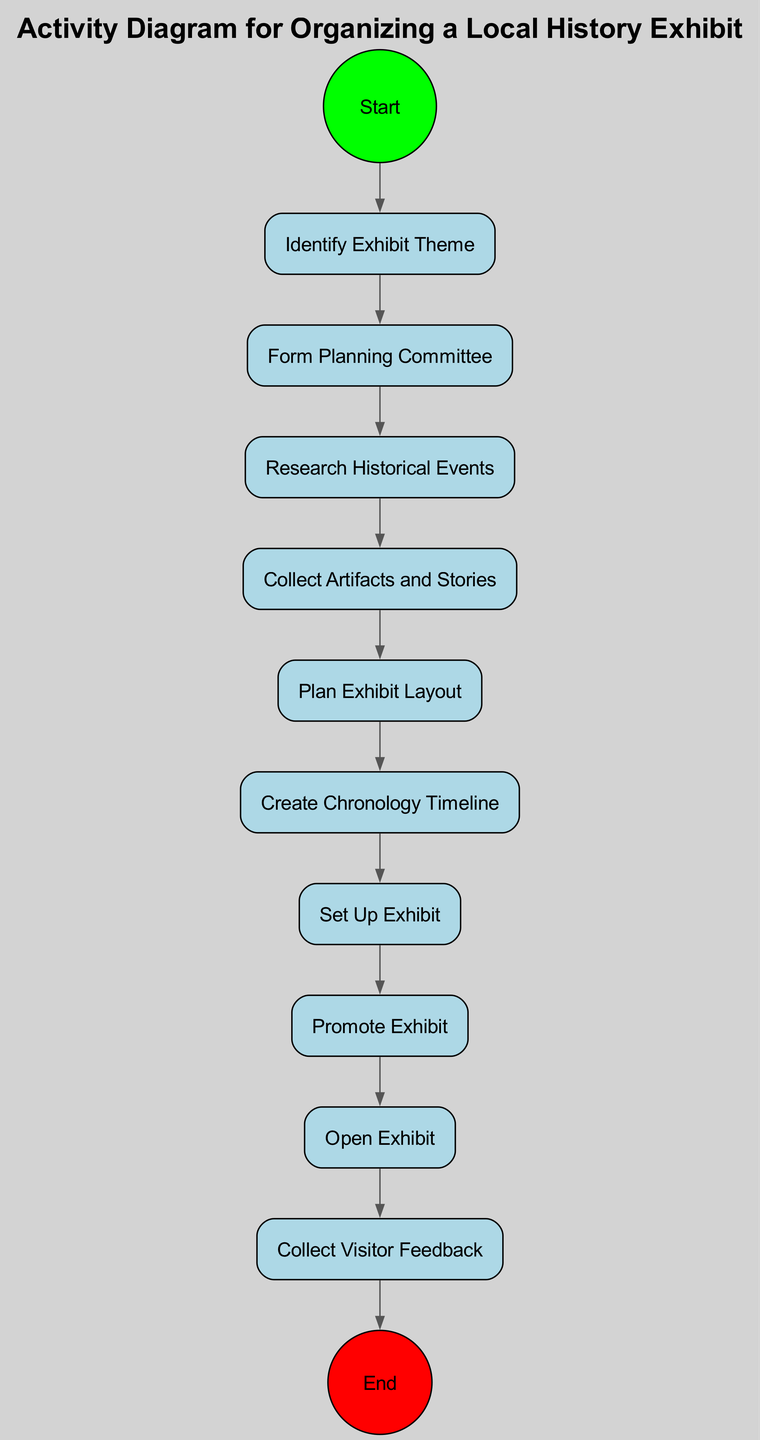What is the first activity in the diagram? The first node after the "Start" event is labeled "Identify Exhibit Theme." This is the first step in organizing the local history exhibit.
Answer: Identify Exhibit Theme How many activities are there in total? By counting all the nodes of type "activity" in the diagram, we find that there are ten activities, from identifying the theme to collecting visitor feedback.
Answer: 10 What node follows "Form Planning Committee"? According to the diagram's flow, the "Form Planning Committee" node directly connects to the next node labeled "Research Historical Events."
Answer: Research Historical Events What is the last activity before the "End" event? The last activity that connects to the "End" event is "Collect Visitor Feedback," indicating that gathering feedback is the final step in the process before concluding.
Answer: Collect Visitor Feedback Which node does "Plan Exhibit Layout" lead to? In the sequence of activities, the node "Plan Exhibit Layout" flows into "Create Chronology Timeline," marking the transition from planning the layout to creating the timeline.
Answer: Create Chronology Timeline How many flows are in the diagram? There are eleven flows present in the diagram, each representing a connection between two nodes, starting from "Start" to "End."
Answer: 11 Which activity comes immediately after "Set Up Exhibit"? The flow of the diagram shows that "Set Up Exhibit" leads directly into the "Promote Exhibit" activity, indicating the next step after setup is promotion.
Answer: Promote Exhibit What does the "Open Exhibit" node lead to? The "Open Exhibit" node has a flow that leads into "Collect Visitor Feedback," indicating that after the exhibit opens, the focus shifts to gathering feedback from visitors.
Answer: Collect Visitor Feedback What is the purpose of the "Create Chronology Timeline" node? The "Create Chronology Timeline" node serves to establish a timeline that likely organizes the historical events for the exhibit, contributing to its structure.
Answer: Establish timeline 